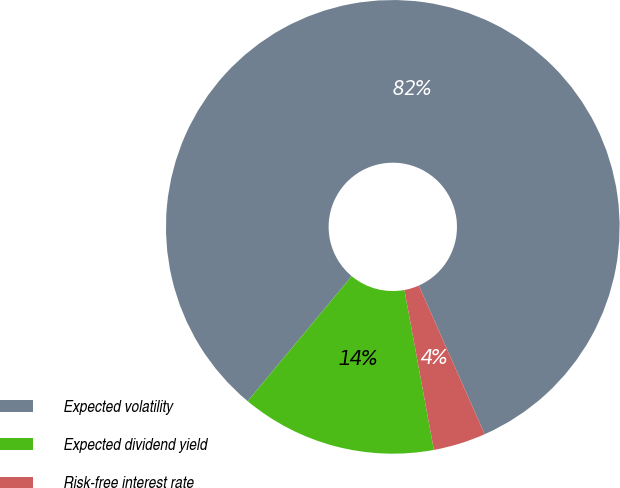Convert chart. <chart><loc_0><loc_0><loc_500><loc_500><pie_chart><fcel>Expected volatility<fcel>Expected dividend yield<fcel>Risk-free interest rate<nl><fcel>82.31%<fcel>13.95%<fcel>3.74%<nl></chart> 